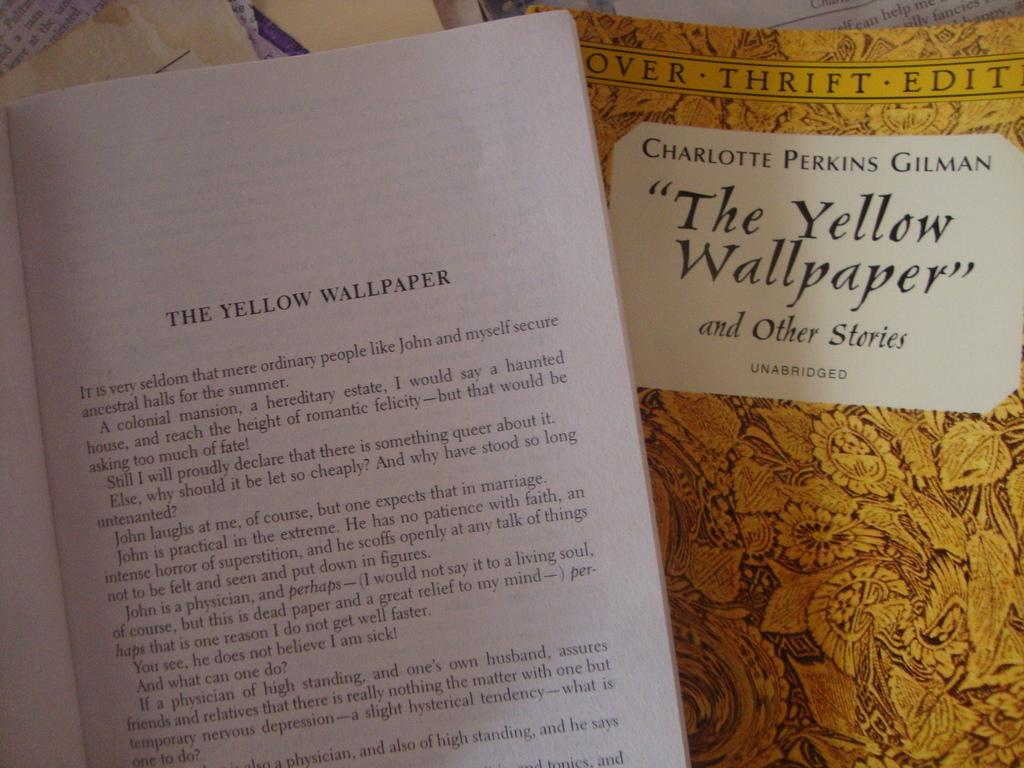<image>
Create a compact narrative representing the image presented. a yellow book that says The Yellow Wallpaper on it 